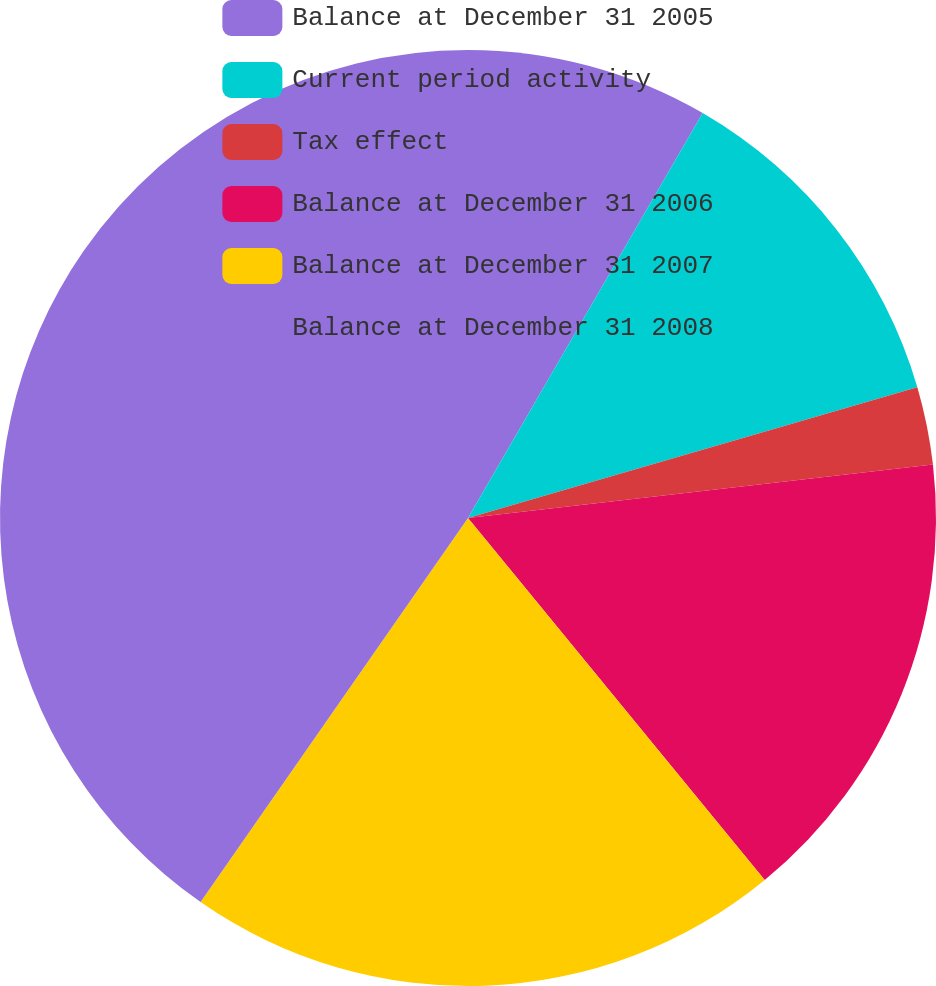Convert chart. <chart><loc_0><loc_0><loc_500><loc_500><pie_chart><fcel>Balance at December 31 2005<fcel>Current period activity<fcel>Tax effect<fcel>Balance at December 31 2006<fcel>Balance at December 31 2007<fcel>Balance at December 31 2008<nl><fcel>8.36%<fcel>12.13%<fcel>2.69%<fcel>15.89%<fcel>20.61%<fcel>40.32%<nl></chart> 